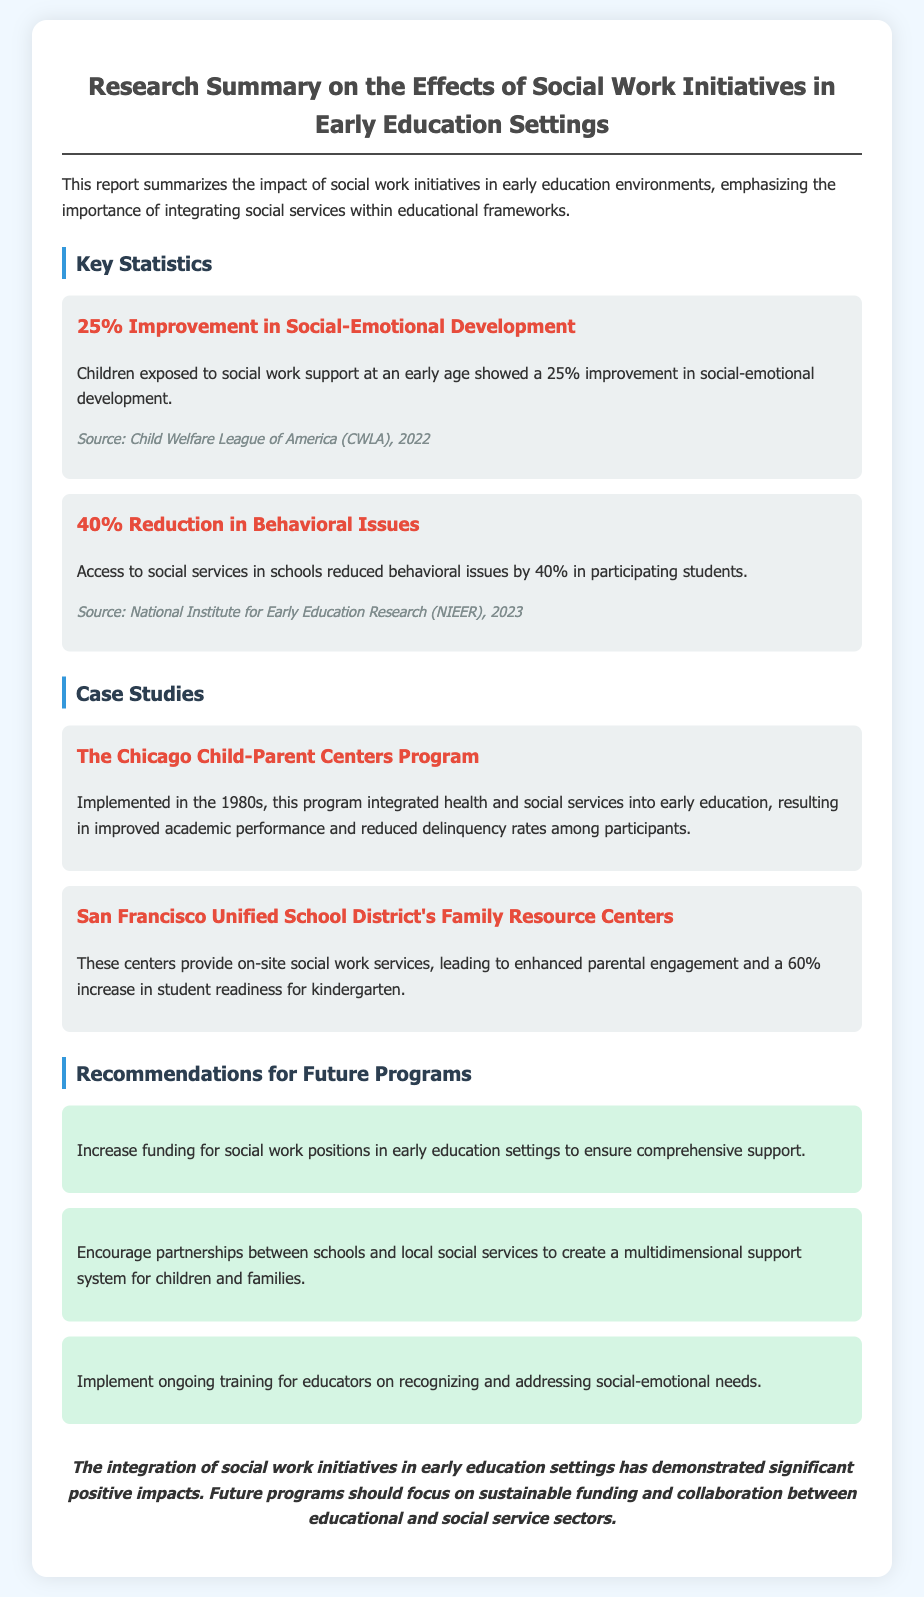What is the percentage improvement in social-emotional development? The document states that children showed a 25% improvement in social-emotional development when exposed to social work support.
Answer: 25% What is the source of the statistic regarding social-emotional development? The document notes that the source for the 25% improvement statistic is the Child Welfare League of America (CWLA), 2022.
Answer: Child Welfare League of America (CWLA), 2022 What was the reduction percentage in behavioral issues reported? According to the document, access to social services in schools led to a 40% reduction in behavioral issues.
Answer: 40% Which program is mentioned as implemented in the 1980s? The document mentions The Chicago Child-Parent Centers Program as a significant initiative from the 1980s focusing on integrating health and social services.
Answer: The Chicago Child-Parent Centers Program What is one recommendation for future programs? The document suggests increasing funding for social work positions in early education settings as a recommendation for future programs.
Answer: Increase funding for social work positions What outcome did the Family Resource Centers achieve? The document states that these centers led to a 60% increase in student readiness for kindergarten.
Answer: 60% How should future programs focus according to the conclusion? The conclusion emphasizes that future programs should focus on sustainable funding and collaboration between educational and social service sectors.
Answer: Sustainable funding and collaboration What color is used for the heading "Recommendations for Future Programs"? The heading "Recommendations for Future Programs" is styled according to the document's CSS, which uses blue for primary elements and gray for secondary ones.
Answer: Blue 